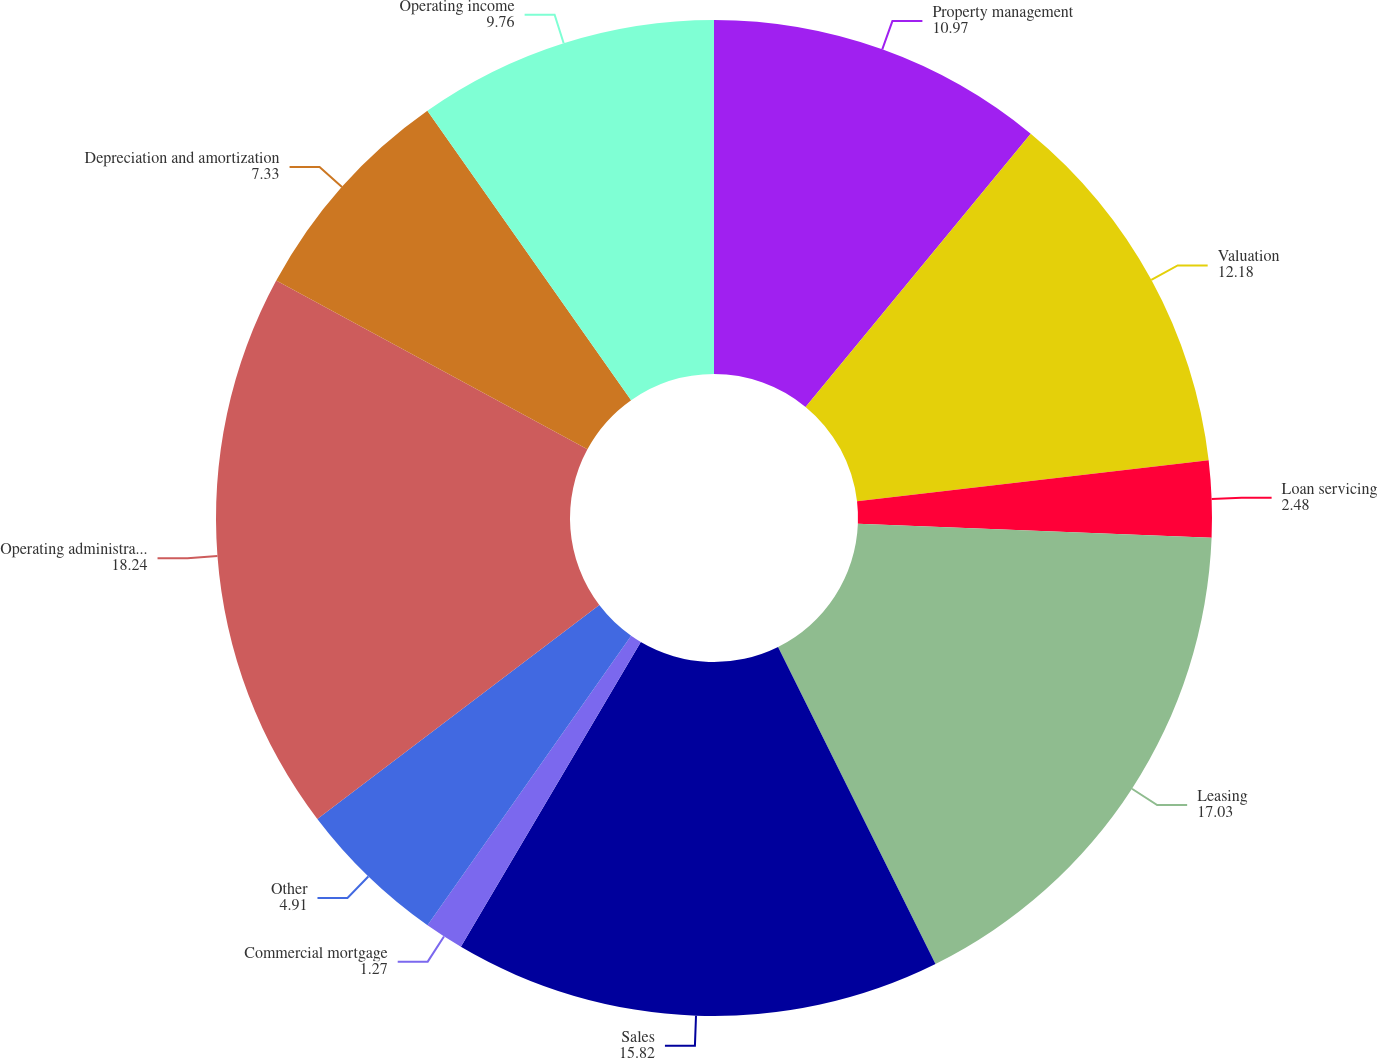Convert chart to OTSL. <chart><loc_0><loc_0><loc_500><loc_500><pie_chart><fcel>Property management<fcel>Valuation<fcel>Loan servicing<fcel>Leasing<fcel>Sales<fcel>Commercial mortgage<fcel>Other<fcel>Operating administrative and<fcel>Depreciation and amortization<fcel>Operating income<nl><fcel>10.97%<fcel>12.18%<fcel>2.48%<fcel>17.03%<fcel>15.82%<fcel>1.27%<fcel>4.91%<fcel>18.24%<fcel>7.33%<fcel>9.76%<nl></chart> 